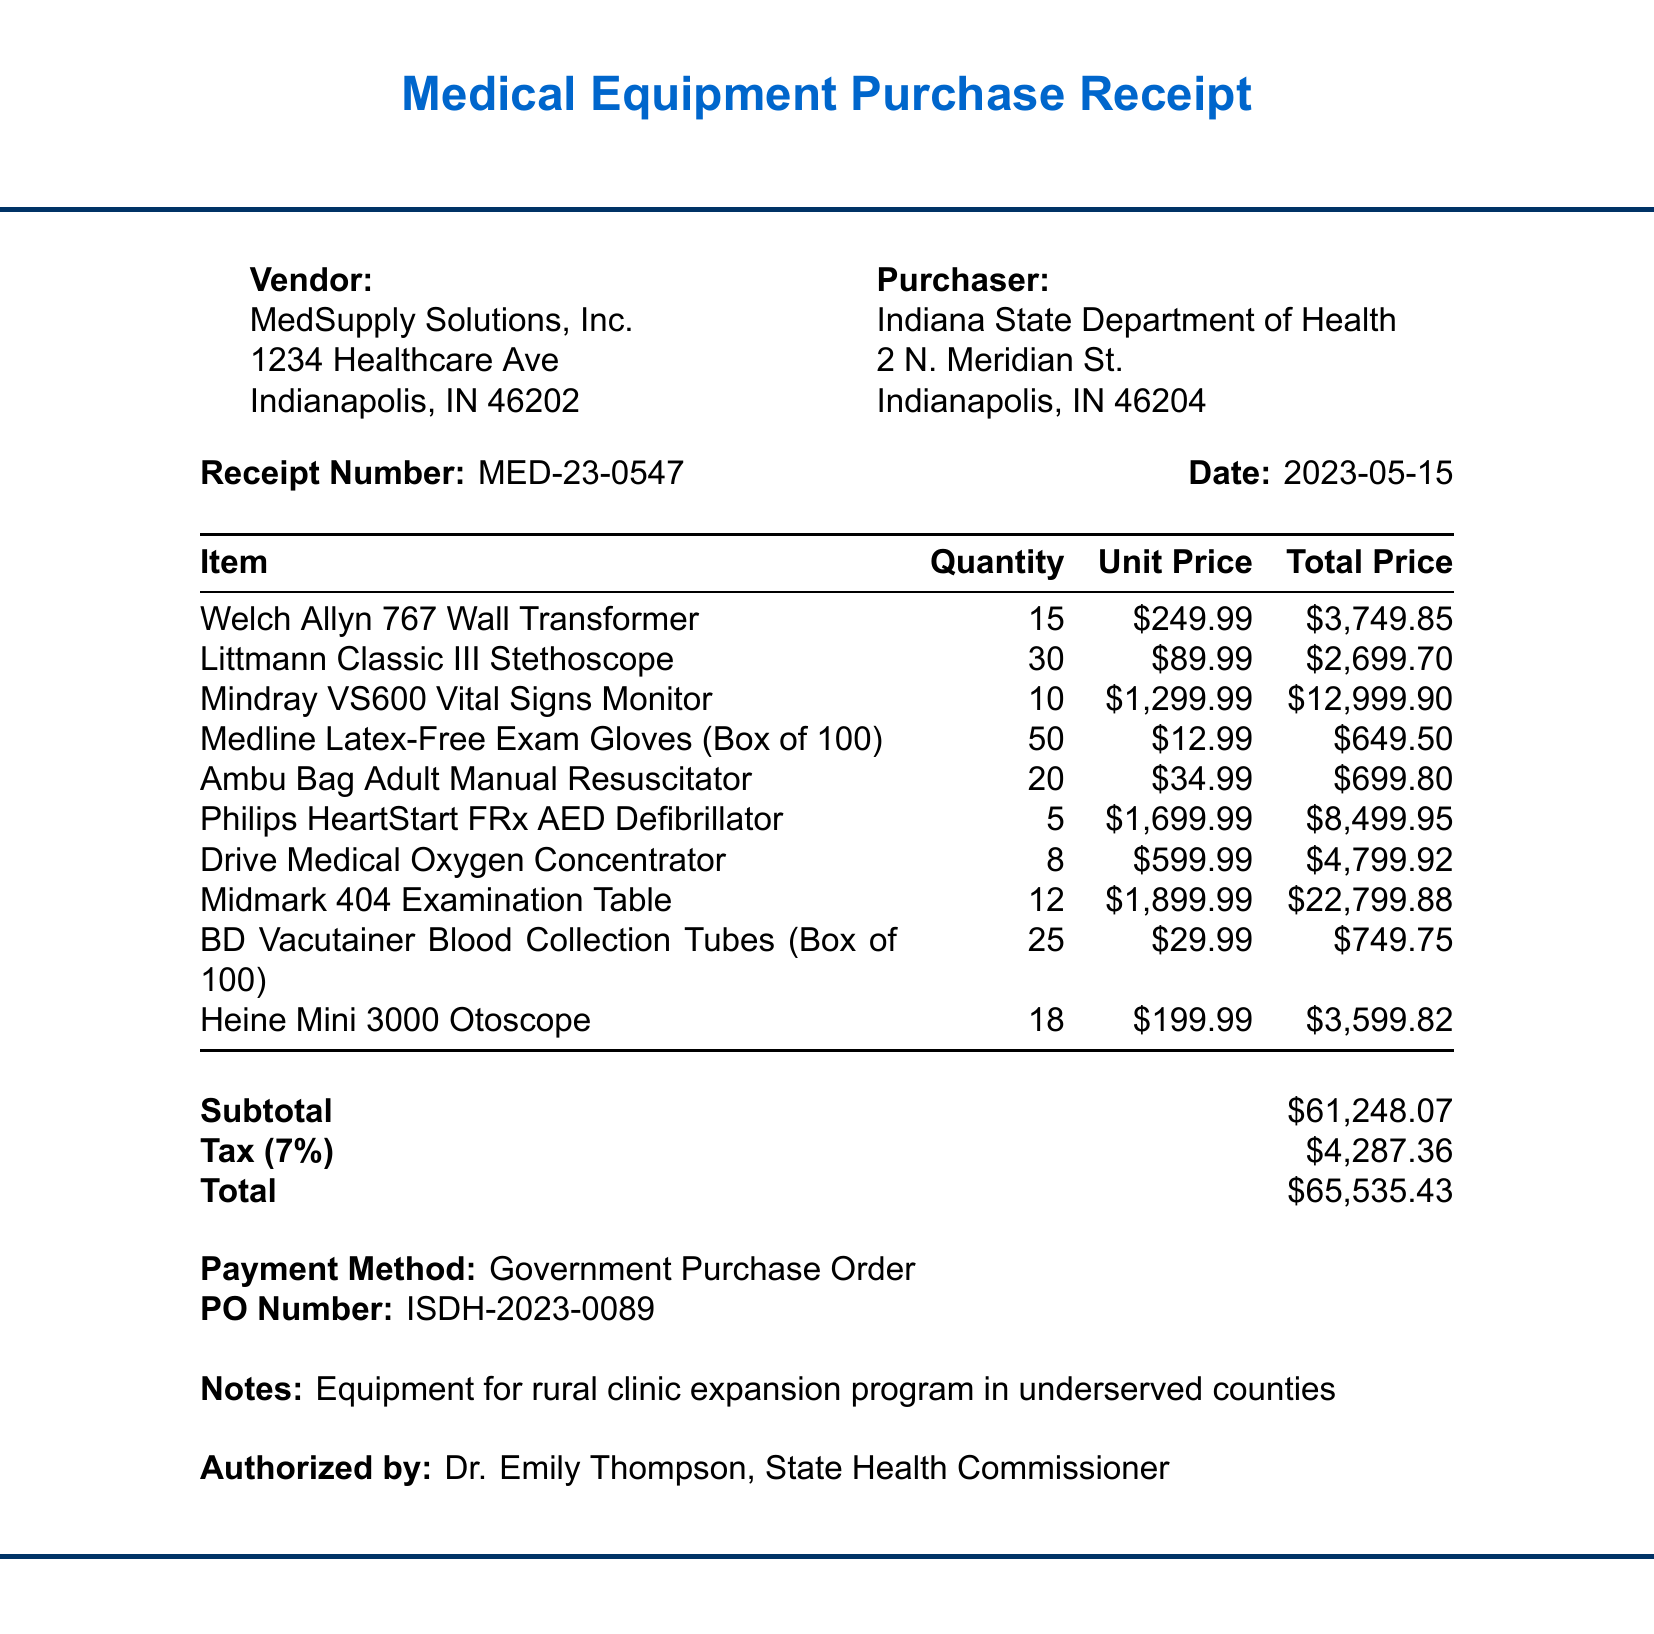What is the receipt number? The receipt number is mentioned at the beginning of the document.
Answer: MED-23-0547 Who is the vendor for the purchase? The vendor's name is provided in the document.
Answer: MedSupply Solutions, Inc What is the total amount on the receipt? The total amount is calculated and presented near the end of the document.
Answer: $65,535.43 How many Welch Allyn 767 Wall Transformers were purchased? The quantity of this specific item is detailed in the item list.
Answer: 15 What was the authorized by title? The document states the title of the person who authorized the purchase.
Answer: State Health Commissioner What is the subtotal before tax? The subtotal is indicated just before the tax amount in the document.
Answer: $61,248.07 What payment method was used? The payment method is specified in the receipt details.
Answer: Government Purchase Order For what purpose was the equipment purchased? The notes at the bottom of the receipt describe the purpose of the purchase.
Answer: rural clinic expansion program in underserved counties How many Philips HeartStart FRx AED Defibrillators were ordered? The quantity of this item is listed alongside other purchased items.
Answer: 5 